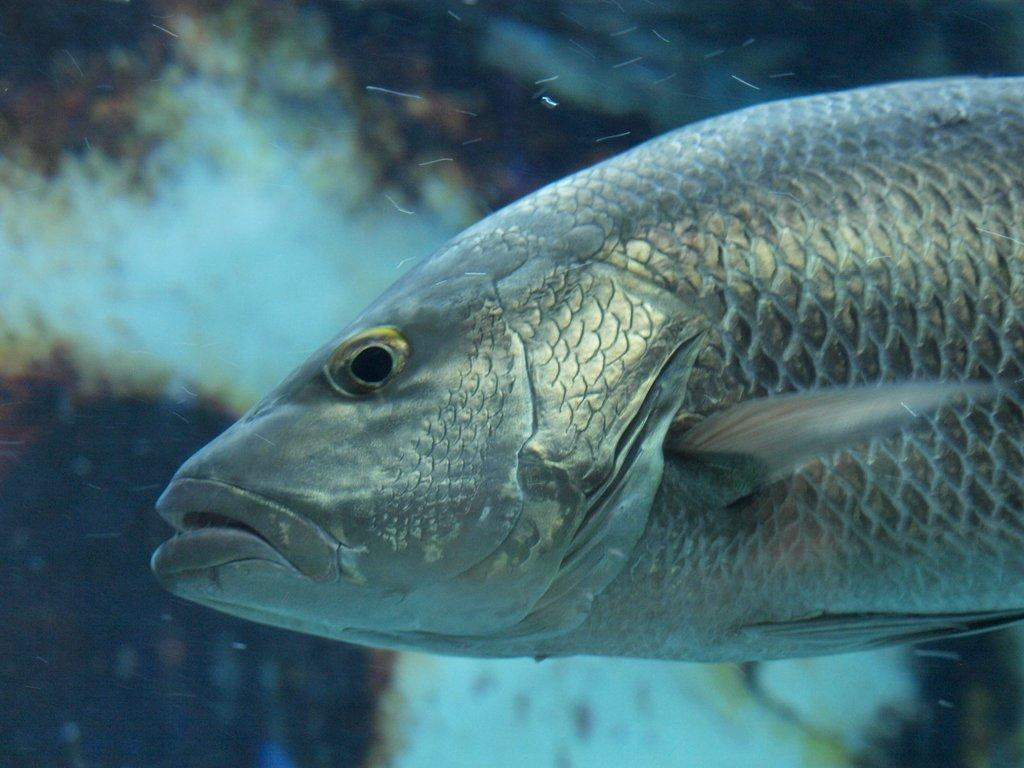What type of animal is in the image? There is a fish in the image. Where is the fish located? The fish is in the water. How many times does the fish express disgust in the image? Fish do not express disgust, and there is no indication of this emotion in the image. 